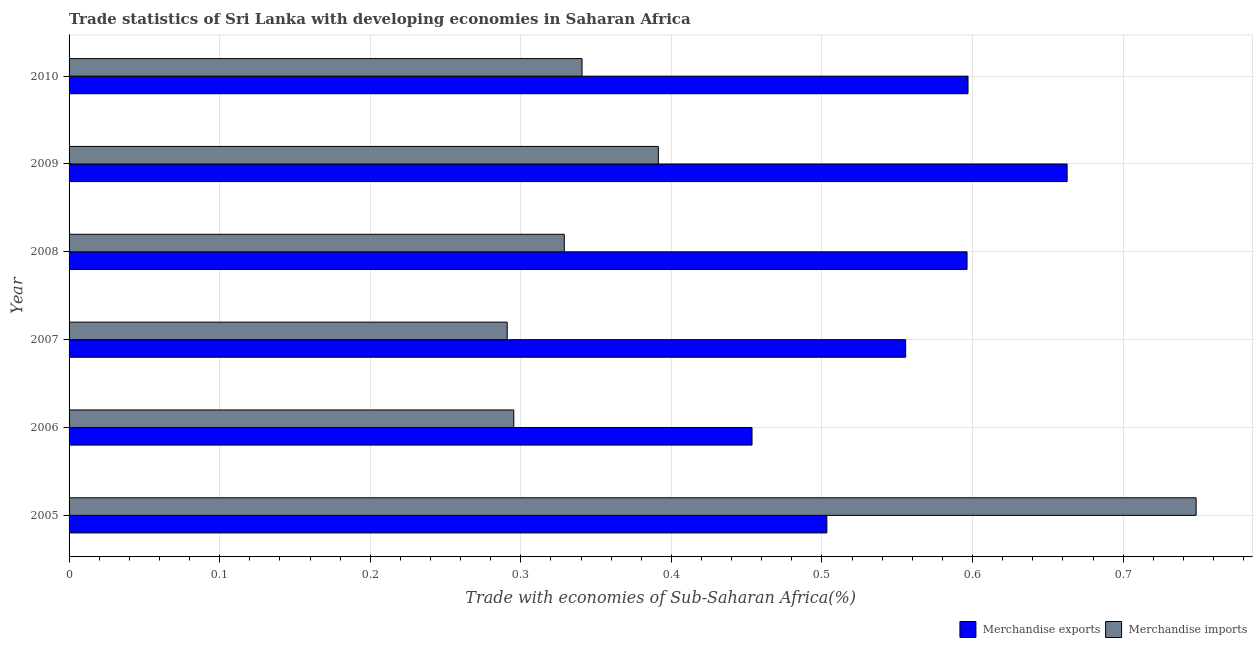Are the number of bars per tick equal to the number of legend labels?
Ensure brevity in your answer.  Yes. What is the merchandise exports in 2006?
Offer a terse response. 0.45. Across all years, what is the maximum merchandise exports?
Provide a short and direct response. 0.66. Across all years, what is the minimum merchandise imports?
Make the answer very short. 0.29. In which year was the merchandise exports maximum?
Your answer should be compact. 2009. What is the total merchandise imports in the graph?
Make the answer very short. 2.4. What is the difference between the merchandise exports in 2009 and the merchandise imports in 2005?
Your answer should be compact. -0.09. What is the average merchandise imports per year?
Provide a short and direct response. 0.4. In the year 2006, what is the difference between the merchandise imports and merchandise exports?
Give a very brief answer. -0.16. In how many years, is the merchandise imports greater than 0.16 %?
Your answer should be compact. 6. What is the ratio of the merchandise imports in 2008 to that in 2010?
Your answer should be compact. 0.96. Is the merchandise imports in 2005 less than that in 2008?
Offer a terse response. No. What is the difference between the highest and the second highest merchandise imports?
Make the answer very short. 0.36. What is the difference between the highest and the lowest merchandise exports?
Make the answer very short. 0.21. In how many years, is the merchandise imports greater than the average merchandise imports taken over all years?
Give a very brief answer. 1. Is the sum of the merchandise imports in 2005 and 2009 greater than the maximum merchandise exports across all years?
Your answer should be compact. Yes. What does the 2nd bar from the bottom in 2006 represents?
Make the answer very short. Merchandise imports. How many bars are there?
Your answer should be compact. 12. Are all the bars in the graph horizontal?
Your response must be concise. Yes. Are the values on the major ticks of X-axis written in scientific E-notation?
Keep it short and to the point. No. Does the graph contain grids?
Your answer should be very brief. Yes. What is the title of the graph?
Offer a very short reply. Trade statistics of Sri Lanka with developing economies in Saharan Africa. What is the label or title of the X-axis?
Ensure brevity in your answer.  Trade with economies of Sub-Saharan Africa(%). What is the label or title of the Y-axis?
Ensure brevity in your answer.  Year. What is the Trade with economies of Sub-Saharan Africa(%) in Merchandise exports in 2005?
Offer a very short reply. 0.5. What is the Trade with economies of Sub-Saharan Africa(%) of Merchandise imports in 2005?
Your answer should be compact. 0.75. What is the Trade with economies of Sub-Saharan Africa(%) of Merchandise exports in 2006?
Provide a short and direct response. 0.45. What is the Trade with economies of Sub-Saharan Africa(%) in Merchandise imports in 2006?
Give a very brief answer. 0.3. What is the Trade with economies of Sub-Saharan Africa(%) in Merchandise exports in 2007?
Keep it short and to the point. 0.56. What is the Trade with economies of Sub-Saharan Africa(%) of Merchandise imports in 2007?
Provide a succinct answer. 0.29. What is the Trade with economies of Sub-Saharan Africa(%) in Merchandise exports in 2008?
Provide a succinct answer. 0.6. What is the Trade with economies of Sub-Saharan Africa(%) of Merchandise imports in 2008?
Keep it short and to the point. 0.33. What is the Trade with economies of Sub-Saharan Africa(%) in Merchandise exports in 2009?
Ensure brevity in your answer.  0.66. What is the Trade with economies of Sub-Saharan Africa(%) in Merchandise imports in 2009?
Your answer should be compact. 0.39. What is the Trade with economies of Sub-Saharan Africa(%) of Merchandise exports in 2010?
Keep it short and to the point. 0.6. What is the Trade with economies of Sub-Saharan Africa(%) in Merchandise imports in 2010?
Keep it short and to the point. 0.34. Across all years, what is the maximum Trade with economies of Sub-Saharan Africa(%) of Merchandise exports?
Give a very brief answer. 0.66. Across all years, what is the maximum Trade with economies of Sub-Saharan Africa(%) of Merchandise imports?
Your response must be concise. 0.75. Across all years, what is the minimum Trade with economies of Sub-Saharan Africa(%) of Merchandise exports?
Ensure brevity in your answer.  0.45. Across all years, what is the minimum Trade with economies of Sub-Saharan Africa(%) of Merchandise imports?
Provide a succinct answer. 0.29. What is the total Trade with economies of Sub-Saharan Africa(%) in Merchandise exports in the graph?
Offer a very short reply. 3.37. What is the total Trade with economies of Sub-Saharan Africa(%) of Merchandise imports in the graph?
Provide a succinct answer. 2.4. What is the difference between the Trade with economies of Sub-Saharan Africa(%) of Merchandise exports in 2005 and that in 2006?
Offer a terse response. 0.05. What is the difference between the Trade with economies of Sub-Saharan Africa(%) in Merchandise imports in 2005 and that in 2006?
Provide a succinct answer. 0.45. What is the difference between the Trade with economies of Sub-Saharan Africa(%) of Merchandise exports in 2005 and that in 2007?
Your answer should be compact. -0.05. What is the difference between the Trade with economies of Sub-Saharan Africa(%) in Merchandise imports in 2005 and that in 2007?
Your answer should be compact. 0.46. What is the difference between the Trade with economies of Sub-Saharan Africa(%) in Merchandise exports in 2005 and that in 2008?
Your response must be concise. -0.09. What is the difference between the Trade with economies of Sub-Saharan Africa(%) in Merchandise imports in 2005 and that in 2008?
Keep it short and to the point. 0.42. What is the difference between the Trade with economies of Sub-Saharan Africa(%) in Merchandise exports in 2005 and that in 2009?
Ensure brevity in your answer.  -0.16. What is the difference between the Trade with economies of Sub-Saharan Africa(%) of Merchandise imports in 2005 and that in 2009?
Offer a terse response. 0.36. What is the difference between the Trade with economies of Sub-Saharan Africa(%) in Merchandise exports in 2005 and that in 2010?
Provide a short and direct response. -0.09. What is the difference between the Trade with economies of Sub-Saharan Africa(%) of Merchandise imports in 2005 and that in 2010?
Provide a succinct answer. 0.41. What is the difference between the Trade with economies of Sub-Saharan Africa(%) in Merchandise exports in 2006 and that in 2007?
Your response must be concise. -0.1. What is the difference between the Trade with economies of Sub-Saharan Africa(%) in Merchandise imports in 2006 and that in 2007?
Your answer should be compact. 0. What is the difference between the Trade with economies of Sub-Saharan Africa(%) of Merchandise exports in 2006 and that in 2008?
Provide a succinct answer. -0.14. What is the difference between the Trade with economies of Sub-Saharan Africa(%) of Merchandise imports in 2006 and that in 2008?
Make the answer very short. -0.03. What is the difference between the Trade with economies of Sub-Saharan Africa(%) of Merchandise exports in 2006 and that in 2009?
Make the answer very short. -0.21. What is the difference between the Trade with economies of Sub-Saharan Africa(%) in Merchandise imports in 2006 and that in 2009?
Your response must be concise. -0.1. What is the difference between the Trade with economies of Sub-Saharan Africa(%) of Merchandise exports in 2006 and that in 2010?
Offer a very short reply. -0.14. What is the difference between the Trade with economies of Sub-Saharan Africa(%) of Merchandise imports in 2006 and that in 2010?
Your answer should be compact. -0.05. What is the difference between the Trade with economies of Sub-Saharan Africa(%) of Merchandise exports in 2007 and that in 2008?
Make the answer very short. -0.04. What is the difference between the Trade with economies of Sub-Saharan Africa(%) of Merchandise imports in 2007 and that in 2008?
Keep it short and to the point. -0.04. What is the difference between the Trade with economies of Sub-Saharan Africa(%) in Merchandise exports in 2007 and that in 2009?
Your answer should be very brief. -0.11. What is the difference between the Trade with economies of Sub-Saharan Africa(%) in Merchandise imports in 2007 and that in 2009?
Offer a terse response. -0.1. What is the difference between the Trade with economies of Sub-Saharan Africa(%) in Merchandise exports in 2007 and that in 2010?
Ensure brevity in your answer.  -0.04. What is the difference between the Trade with economies of Sub-Saharan Africa(%) in Merchandise imports in 2007 and that in 2010?
Ensure brevity in your answer.  -0.05. What is the difference between the Trade with economies of Sub-Saharan Africa(%) in Merchandise exports in 2008 and that in 2009?
Ensure brevity in your answer.  -0.07. What is the difference between the Trade with economies of Sub-Saharan Africa(%) in Merchandise imports in 2008 and that in 2009?
Your response must be concise. -0.06. What is the difference between the Trade with economies of Sub-Saharan Africa(%) in Merchandise exports in 2008 and that in 2010?
Keep it short and to the point. -0. What is the difference between the Trade with economies of Sub-Saharan Africa(%) in Merchandise imports in 2008 and that in 2010?
Offer a terse response. -0.01. What is the difference between the Trade with economies of Sub-Saharan Africa(%) in Merchandise exports in 2009 and that in 2010?
Offer a very short reply. 0.07. What is the difference between the Trade with economies of Sub-Saharan Africa(%) of Merchandise imports in 2009 and that in 2010?
Your answer should be compact. 0.05. What is the difference between the Trade with economies of Sub-Saharan Africa(%) in Merchandise exports in 2005 and the Trade with economies of Sub-Saharan Africa(%) in Merchandise imports in 2006?
Your response must be concise. 0.21. What is the difference between the Trade with economies of Sub-Saharan Africa(%) in Merchandise exports in 2005 and the Trade with economies of Sub-Saharan Africa(%) in Merchandise imports in 2007?
Keep it short and to the point. 0.21. What is the difference between the Trade with economies of Sub-Saharan Africa(%) of Merchandise exports in 2005 and the Trade with economies of Sub-Saharan Africa(%) of Merchandise imports in 2008?
Your answer should be compact. 0.17. What is the difference between the Trade with economies of Sub-Saharan Africa(%) in Merchandise exports in 2005 and the Trade with economies of Sub-Saharan Africa(%) in Merchandise imports in 2009?
Your answer should be compact. 0.11. What is the difference between the Trade with economies of Sub-Saharan Africa(%) of Merchandise exports in 2005 and the Trade with economies of Sub-Saharan Africa(%) of Merchandise imports in 2010?
Your answer should be compact. 0.16. What is the difference between the Trade with economies of Sub-Saharan Africa(%) of Merchandise exports in 2006 and the Trade with economies of Sub-Saharan Africa(%) of Merchandise imports in 2007?
Give a very brief answer. 0.16. What is the difference between the Trade with economies of Sub-Saharan Africa(%) of Merchandise exports in 2006 and the Trade with economies of Sub-Saharan Africa(%) of Merchandise imports in 2008?
Give a very brief answer. 0.12. What is the difference between the Trade with economies of Sub-Saharan Africa(%) in Merchandise exports in 2006 and the Trade with economies of Sub-Saharan Africa(%) in Merchandise imports in 2009?
Offer a very short reply. 0.06. What is the difference between the Trade with economies of Sub-Saharan Africa(%) of Merchandise exports in 2006 and the Trade with economies of Sub-Saharan Africa(%) of Merchandise imports in 2010?
Your answer should be very brief. 0.11. What is the difference between the Trade with economies of Sub-Saharan Africa(%) of Merchandise exports in 2007 and the Trade with economies of Sub-Saharan Africa(%) of Merchandise imports in 2008?
Offer a very short reply. 0.23. What is the difference between the Trade with economies of Sub-Saharan Africa(%) of Merchandise exports in 2007 and the Trade with economies of Sub-Saharan Africa(%) of Merchandise imports in 2009?
Ensure brevity in your answer.  0.16. What is the difference between the Trade with economies of Sub-Saharan Africa(%) of Merchandise exports in 2007 and the Trade with economies of Sub-Saharan Africa(%) of Merchandise imports in 2010?
Your answer should be very brief. 0.21. What is the difference between the Trade with economies of Sub-Saharan Africa(%) of Merchandise exports in 2008 and the Trade with economies of Sub-Saharan Africa(%) of Merchandise imports in 2009?
Make the answer very short. 0.2. What is the difference between the Trade with economies of Sub-Saharan Africa(%) of Merchandise exports in 2008 and the Trade with economies of Sub-Saharan Africa(%) of Merchandise imports in 2010?
Ensure brevity in your answer.  0.26. What is the difference between the Trade with economies of Sub-Saharan Africa(%) in Merchandise exports in 2009 and the Trade with economies of Sub-Saharan Africa(%) in Merchandise imports in 2010?
Make the answer very short. 0.32. What is the average Trade with economies of Sub-Saharan Africa(%) of Merchandise exports per year?
Offer a terse response. 0.56. What is the average Trade with economies of Sub-Saharan Africa(%) in Merchandise imports per year?
Keep it short and to the point. 0.4. In the year 2005, what is the difference between the Trade with economies of Sub-Saharan Africa(%) in Merchandise exports and Trade with economies of Sub-Saharan Africa(%) in Merchandise imports?
Your answer should be very brief. -0.25. In the year 2006, what is the difference between the Trade with economies of Sub-Saharan Africa(%) of Merchandise exports and Trade with economies of Sub-Saharan Africa(%) of Merchandise imports?
Your answer should be compact. 0.16. In the year 2007, what is the difference between the Trade with economies of Sub-Saharan Africa(%) in Merchandise exports and Trade with economies of Sub-Saharan Africa(%) in Merchandise imports?
Offer a very short reply. 0.26. In the year 2008, what is the difference between the Trade with economies of Sub-Saharan Africa(%) of Merchandise exports and Trade with economies of Sub-Saharan Africa(%) of Merchandise imports?
Your answer should be very brief. 0.27. In the year 2009, what is the difference between the Trade with economies of Sub-Saharan Africa(%) of Merchandise exports and Trade with economies of Sub-Saharan Africa(%) of Merchandise imports?
Offer a very short reply. 0.27. In the year 2010, what is the difference between the Trade with economies of Sub-Saharan Africa(%) of Merchandise exports and Trade with economies of Sub-Saharan Africa(%) of Merchandise imports?
Your answer should be very brief. 0.26. What is the ratio of the Trade with economies of Sub-Saharan Africa(%) of Merchandise exports in 2005 to that in 2006?
Keep it short and to the point. 1.11. What is the ratio of the Trade with economies of Sub-Saharan Africa(%) of Merchandise imports in 2005 to that in 2006?
Make the answer very short. 2.53. What is the ratio of the Trade with economies of Sub-Saharan Africa(%) in Merchandise exports in 2005 to that in 2007?
Keep it short and to the point. 0.91. What is the ratio of the Trade with economies of Sub-Saharan Africa(%) of Merchandise imports in 2005 to that in 2007?
Ensure brevity in your answer.  2.57. What is the ratio of the Trade with economies of Sub-Saharan Africa(%) of Merchandise exports in 2005 to that in 2008?
Give a very brief answer. 0.84. What is the ratio of the Trade with economies of Sub-Saharan Africa(%) of Merchandise imports in 2005 to that in 2008?
Provide a short and direct response. 2.28. What is the ratio of the Trade with economies of Sub-Saharan Africa(%) of Merchandise exports in 2005 to that in 2009?
Your response must be concise. 0.76. What is the ratio of the Trade with economies of Sub-Saharan Africa(%) of Merchandise imports in 2005 to that in 2009?
Your answer should be compact. 1.91. What is the ratio of the Trade with economies of Sub-Saharan Africa(%) in Merchandise exports in 2005 to that in 2010?
Keep it short and to the point. 0.84. What is the ratio of the Trade with economies of Sub-Saharan Africa(%) in Merchandise imports in 2005 to that in 2010?
Provide a succinct answer. 2.2. What is the ratio of the Trade with economies of Sub-Saharan Africa(%) of Merchandise exports in 2006 to that in 2007?
Your response must be concise. 0.82. What is the ratio of the Trade with economies of Sub-Saharan Africa(%) in Merchandise imports in 2006 to that in 2007?
Provide a succinct answer. 1.01. What is the ratio of the Trade with economies of Sub-Saharan Africa(%) of Merchandise exports in 2006 to that in 2008?
Your answer should be very brief. 0.76. What is the ratio of the Trade with economies of Sub-Saharan Africa(%) in Merchandise imports in 2006 to that in 2008?
Your answer should be very brief. 0.9. What is the ratio of the Trade with economies of Sub-Saharan Africa(%) of Merchandise exports in 2006 to that in 2009?
Provide a succinct answer. 0.68. What is the ratio of the Trade with economies of Sub-Saharan Africa(%) in Merchandise imports in 2006 to that in 2009?
Offer a very short reply. 0.75. What is the ratio of the Trade with economies of Sub-Saharan Africa(%) in Merchandise exports in 2006 to that in 2010?
Make the answer very short. 0.76. What is the ratio of the Trade with economies of Sub-Saharan Africa(%) of Merchandise imports in 2006 to that in 2010?
Your response must be concise. 0.87. What is the ratio of the Trade with economies of Sub-Saharan Africa(%) of Merchandise exports in 2007 to that in 2008?
Provide a succinct answer. 0.93. What is the ratio of the Trade with economies of Sub-Saharan Africa(%) of Merchandise imports in 2007 to that in 2008?
Provide a short and direct response. 0.88. What is the ratio of the Trade with economies of Sub-Saharan Africa(%) in Merchandise exports in 2007 to that in 2009?
Your answer should be compact. 0.84. What is the ratio of the Trade with economies of Sub-Saharan Africa(%) of Merchandise imports in 2007 to that in 2009?
Your answer should be compact. 0.74. What is the ratio of the Trade with economies of Sub-Saharan Africa(%) of Merchandise exports in 2007 to that in 2010?
Provide a succinct answer. 0.93. What is the ratio of the Trade with economies of Sub-Saharan Africa(%) in Merchandise imports in 2007 to that in 2010?
Give a very brief answer. 0.85. What is the ratio of the Trade with economies of Sub-Saharan Africa(%) of Merchandise exports in 2008 to that in 2009?
Offer a terse response. 0.9. What is the ratio of the Trade with economies of Sub-Saharan Africa(%) in Merchandise imports in 2008 to that in 2009?
Keep it short and to the point. 0.84. What is the ratio of the Trade with economies of Sub-Saharan Africa(%) of Merchandise imports in 2008 to that in 2010?
Give a very brief answer. 0.97. What is the ratio of the Trade with economies of Sub-Saharan Africa(%) of Merchandise exports in 2009 to that in 2010?
Ensure brevity in your answer.  1.11. What is the ratio of the Trade with economies of Sub-Saharan Africa(%) in Merchandise imports in 2009 to that in 2010?
Your answer should be compact. 1.15. What is the difference between the highest and the second highest Trade with economies of Sub-Saharan Africa(%) in Merchandise exports?
Your answer should be very brief. 0.07. What is the difference between the highest and the second highest Trade with economies of Sub-Saharan Africa(%) of Merchandise imports?
Provide a succinct answer. 0.36. What is the difference between the highest and the lowest Trade with economies of Sub-Saharan Africa(%) of Merchandise exports?
Provide a succinct answer. 0.21. What is the difference between the highest and the lowest Trade with economies of Sub-Saharan Africa(%) in Merchandise imports?
Offer a very short reply. 0.46. 